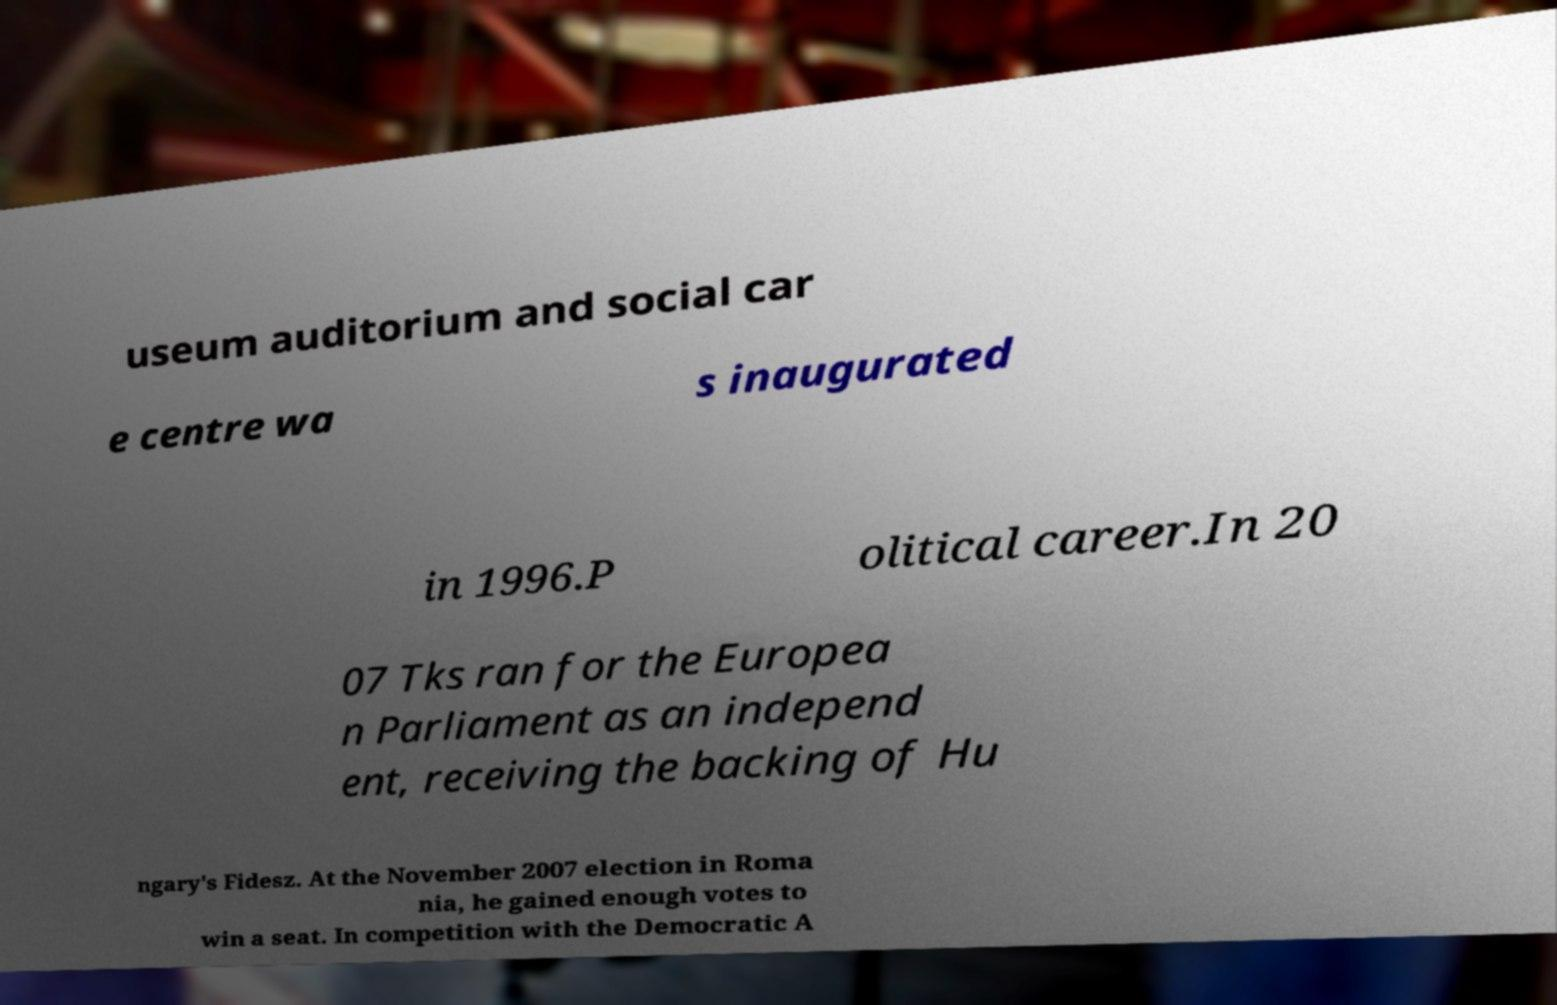Can you accurately transcribe the text from the provided image for me? useum auditorium and social car e centre wa s inaugurated in 1996.P olitical career.In 20 07 Tks ran for the Europea n Parliament as an independ ent, receiving the backing of Hu ngary's Fidesz. At the November 2007 election in Roma nia, he gained enough votes to win a seat. In competition with the Democratic A 